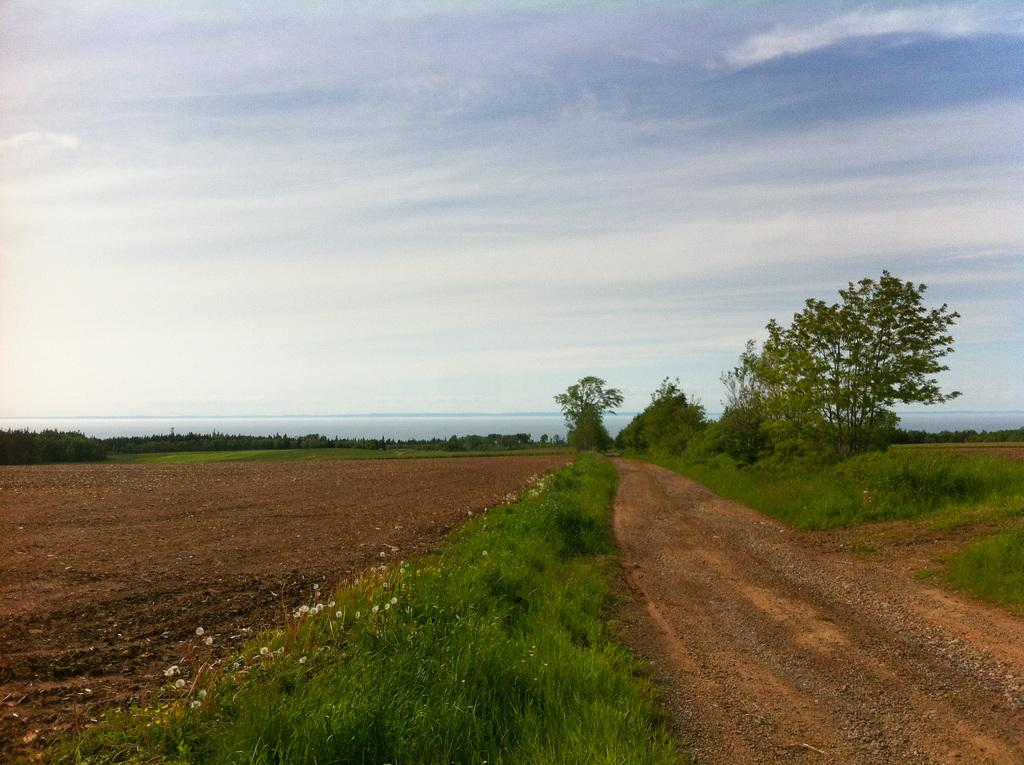What type of vegetation can be seen in the image? There is grass, plants, and trees visible in the image. What part of the natural environment is visible in the image? The sky is visible in the background of the image. What type of calculator can be seen in the image? There is no calculator present in the image. What type of smile can be seen on the trees in the image? Trees do not have the ability to smile, so there is no smile present on the trees in the image. 